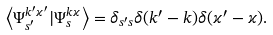Convert formula to latex. <formula><loc_0><loc_0><loc_500><loc_500>\left \langle \Psi ^ { k ^ { \prime } \varkappa ^ { \prime } } _ { s ^ { \prime } } | \Psi ^ { k \varkappa } _ { s } \right \rangle = \delta _ { s ^ { \prime } s } \delta ( k ^ { \prime } - k ) \delta ( \varkappa ^ { \prime } - \varkappa ) .</formula> 